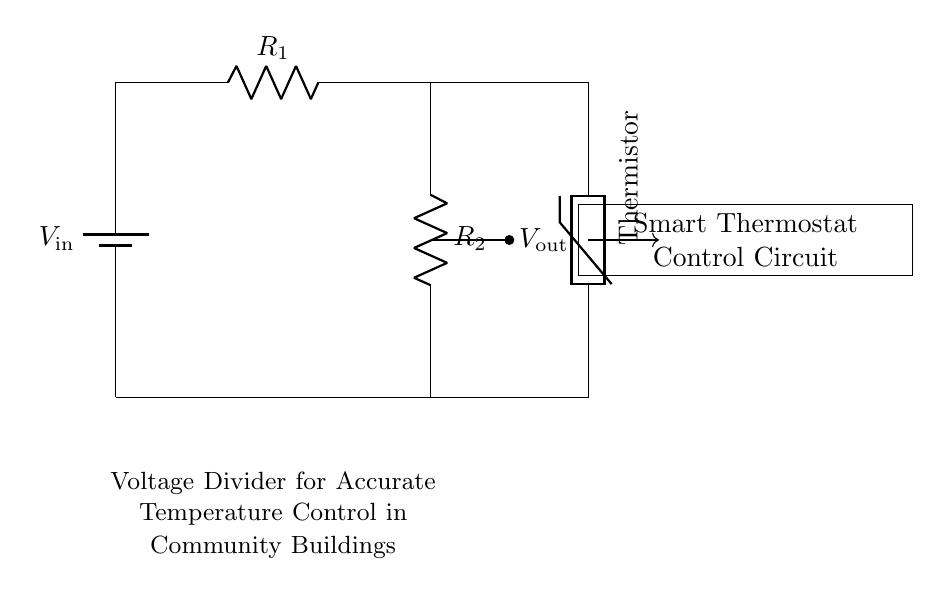What is the input voltage of the circuit? The input voltage is labeled as V in at the top of the circuit diagram, indicating the source voltage supplied to the circuit.
Answer: V in What components are present in this circuit? The circuit contains a battery, two resistors (R1 and R2), and a thermistor. These components are labeled in the diagram, allowing us to identify them easily.
Answer: Battery, R1, R2, Thermistor What does V out represent in this circuit? V out, shown in the middle of the diagram, is the output voltage of the voltage divider circuit, which is the voltage across R2 that is used to control the thermostat.
Answer: Output voltage How does the thermistor affect the output voltage? The thermistor is sensitive to temperature changes, and its resistance will affect the voltage across R2. This in turn influences V out, making the temperature control more responsive.
Answer: It adjusts the output voltage What is the purpose of using a voltage divider in smart thermostats? A voltage divider is used to scale down the voltage to a specific range that can be accurately read by the control circuit of the thermostat, improving temperature measurement and regulation.
Answer: Improved temperature control What is the total resistance in this circuit if R1 is 2000 ohms and R2 is 1000 ohms? The total resistance in a voltage divider circuit is simply the sum of R1 and R2, so the total resistance would be 2000 ohms plus 1000 ohms. Therefore, it computes to 3000 ohms.
Answer: 3000 ohms How does increasing R1 affect V out? Increasing R1 would decrease V out because a larger portion of the input voltage would drop across R1, leading to a lower voltage across R2. The division of voltage depends on the resistance proportions in the circuit.
Answer: Decreases V out 